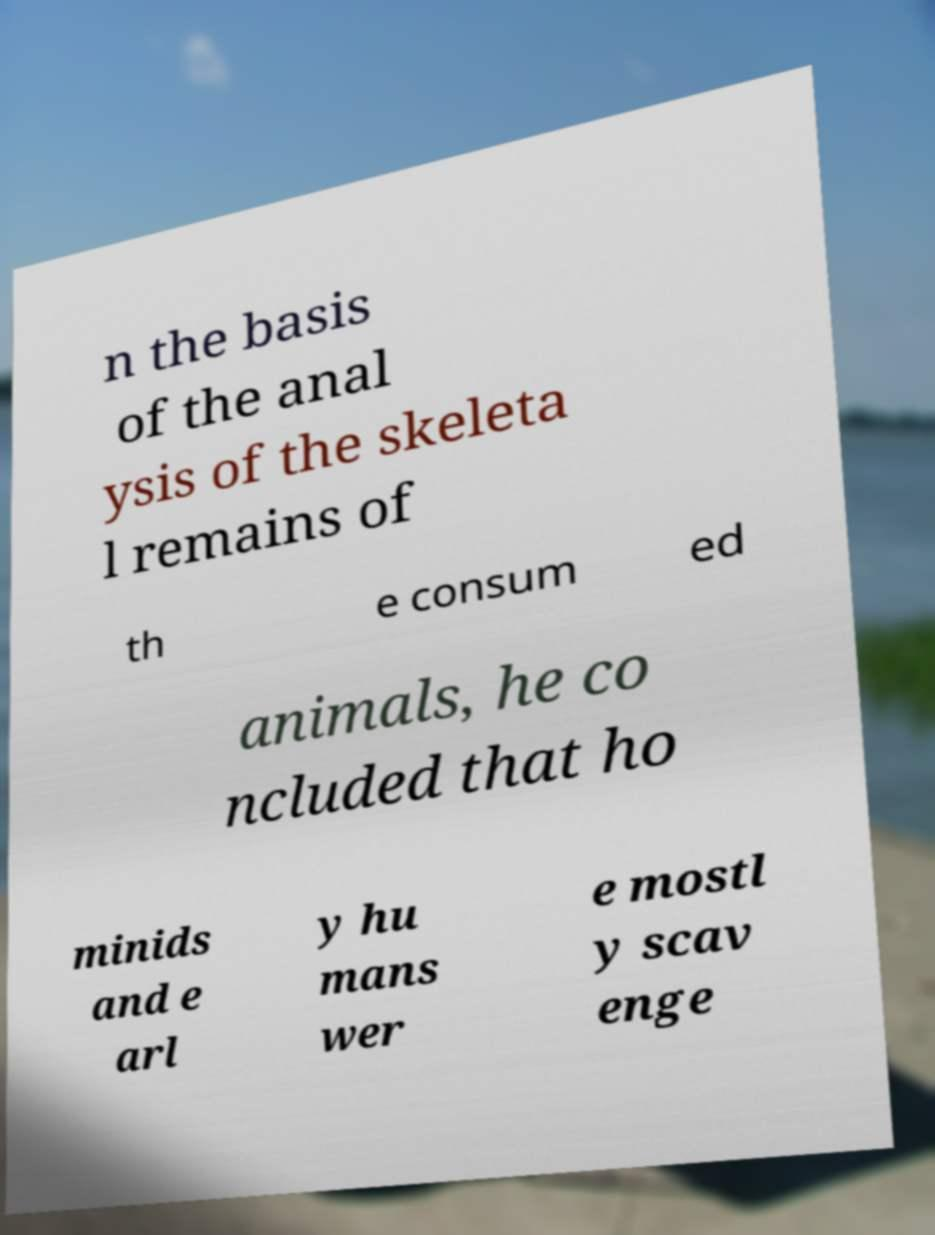Please read and relay the text visible in this image. What does it say? n the basis of the anal ysis of the skeleta l remains of th e consum ed animals, he co ncluded that ho minids and e arl y hu mans wer e mostl y scav enge 